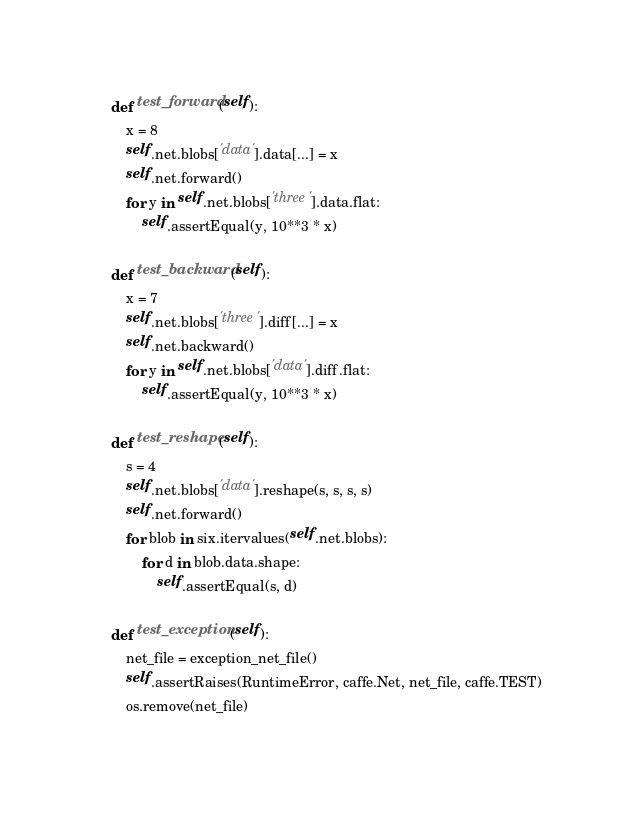Convert code to text. <code><loc_0><loc_0><loc_500><loc_500><_Python_>
    def test_forward(self):
        x = 8
        self.net.blobs['data'].data[...] = x
        self.net.forward()
        for y in self.net.blobs['three'].data.flat:
            self.assertEqual(y, 10**3 * x)

    def test_backward(self):
        x = 7
        self.net.blobs['three'].diff[...] = x
        self.net.backward()
        for y in self.net.blobs['data'].diff.flat:
            self.assertEqual(y, 10**3 * x)

    def test_reshape(self):
        s = 4
        self.net.blobs['data'].reshape(s, s, s, s)
        self.net.forward()
        for blob in six.itervalues(self.net.blobs):
            for d in blob.data.shape:
                self.assertEqual(s, d)

    def test_exception(self):
        net_file = exception_net_file()
        self.assertRaises(RuntimeError, caffe.Net, net_file, caffe.TEST)
        os.remove(net_file)
</code> 